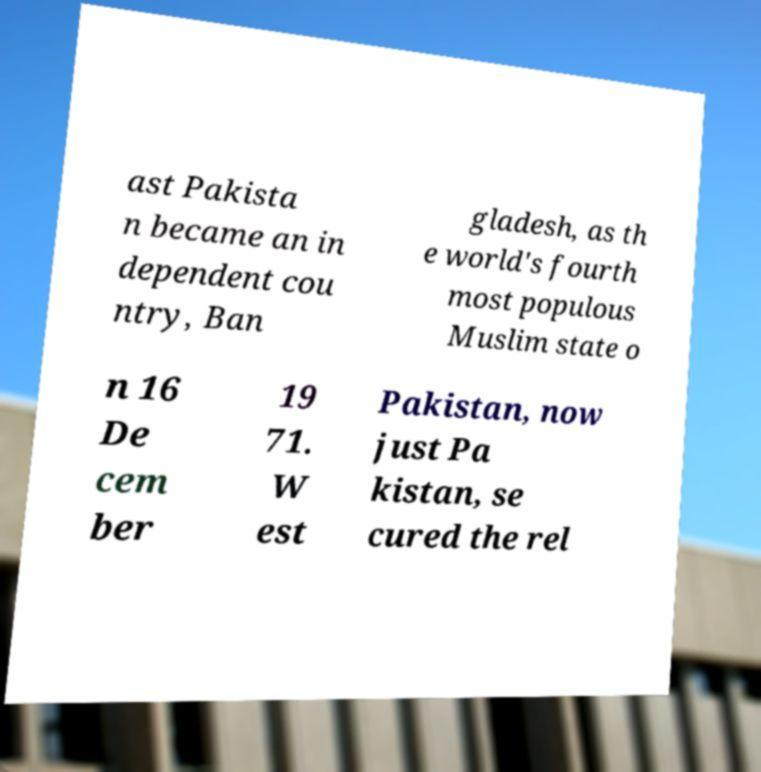Please identify and transcribe the text found in this image. ast Pakista n became an in dependent cou ntry, Ban gladesh, as th e world's fourth most populous Muslim state o n 16 De cem ber 19 71. W est Pakistan, now just Pa kistan, se cured the rel 